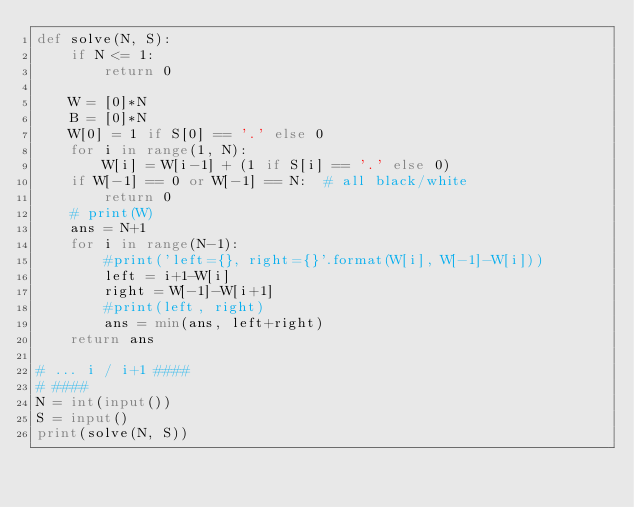Convert code to text. <code><loc_0><loc_0><loc_500><loc_500><_Python_>def solve(N, S):
    if N <= 1:
        return 0

    W = [0]*N
    B = [0]*N
    W[0] = 1 if S[0] == '.' else 0
    for i in range(1, N):
        W[i] = W[i-1] + (1 if S[i] == '.' else 0)
    if W[-1] == 0 or W[-1] == N:  # all black/white
        return 0
    # print(W)
    ans = N+1
    for i in range(N-1):
        #print('left={}, right={}'.format(W[i], W[-1]-W[i]))
        left = i+1-W[i]
        right = W[-1]-W[i+1]
        #print(left, right)
        ans = min(ans, left+right)
    return ans

# ... i / i+1 ####
# ####
N = int(input())
S = input()
print(solve(N, S))</code> 